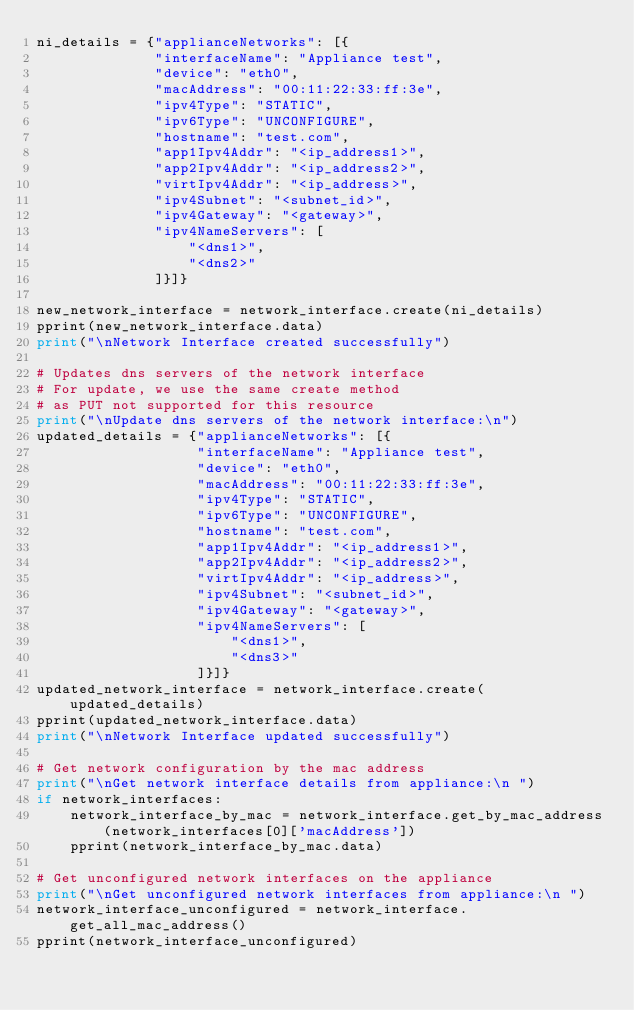<code> <loc_0><loc_0><loc_500><loc_500><_Python_>ni_details = {"applianceNetworks": [{
              "interfaceName": "Appliance test",
              "device": "eth0",
              "macAddress": "00:11:22:33:ff:3e",
              "ipv4Type": "STATIC",
              "ipv6Type": "UNCONFIGURE",
              "hostname": "test.com",
              "app1Ipv4Addr": "<ip_address1>",
              "app2Ipv4Addr": "<ip_address2>",
              "virtIpv4Addr": "<ip_address>",
              "ipv4Subnet": "<subnet_id>",
              "ipv4Gateway": "<gateway>",
              "ipv4NameServers": [
                  "<dns1>",
                  "<dns2>"
              ]}]}

new_network_interface = network_interface.create(ni_details)
pprint(new_network_interface.data)
print("\nNetwork Interface created successfully")

# Updates dns servers of the network interface
# For update, we use the same create method
# as PUT not supported for this resource
print("\nUpdate dns servers of the network interface:\n")
updated_details = {"applianceNetworks": [{
                   "interfaceName": "Appliance test",
                   "device": "eth0",
                   "macAddress": "00:11:22:33:ff:3e",
                   "ipv4Type": "STATIC",
                   "ipv6Type": "UNCONFIGURE",
                   "hostname": "test.com",
                   "app1Ipv4Addr": "<ip_address1>",
                   "app2Ipv4Addr": "<ip_address2>",
                   "virtIpv4Addr": "<ip_address>",
                   "ipv4Subnet": "<subnet_id>",
                   "ipv4Gateway": "<gateway>",
                   "ipv4NameServers": [
                       "<dns1>",
                       "<dns3>"
                   ]}]}
updated_network_interface = network_interface.create(updated_details)
pprint(updated_network_interface.data)
print("\nNetwork Interface updated successfully")

# Get network configuration by the mac address
print("\nGet network interface details from appliance:\n ")
if network_interfaces:
    network_interface_by_mac = network_interface.get_by_mac_address(network_interfaces[0]['macAddress'])
    pprint(network_interface_by_mac.data)

# Get unconfigured network interfaces on the appliance
print("\nGet unconfigured network interfaces from appliance:\n ")
network_interface_unconfigured = network_interface.get_all_mac_address()
pprint(network_interface_unconfigured)
</code> 